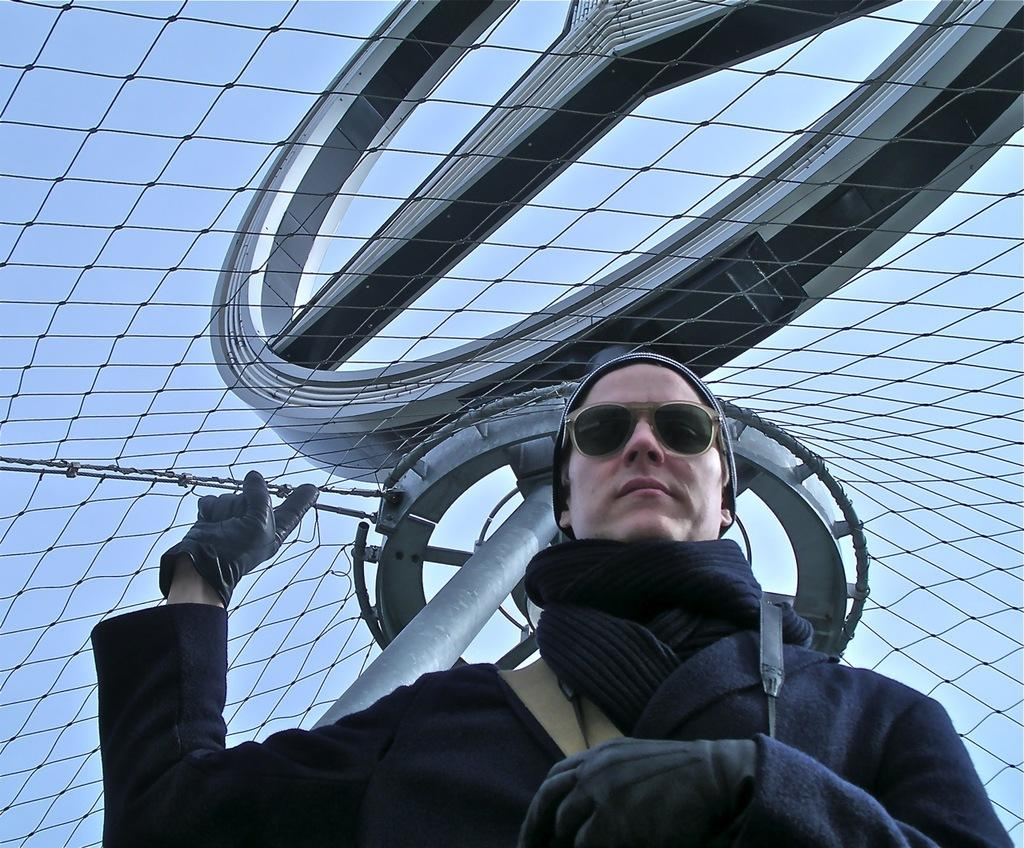What can be seen in the image? There is a person in the image. What is the person wearing? The person is wearing gloves, a sweater, glasses, and a cap. What is visible in the background of the image? There is a net and a symbol in the background of the image. What type of breakfast is the person eating in the image? There is no breakfast present in the image; it only shows a person wearing gloves, a sweater, glasses, and a cap, with a net and a symbol in the background. 